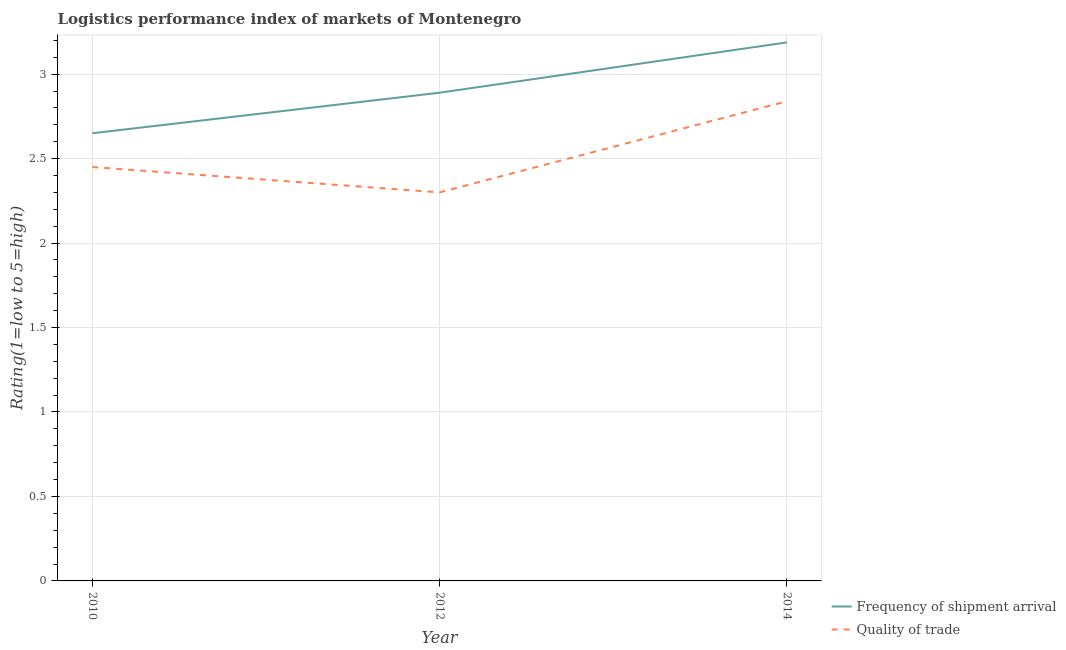Is the number of lines equal to the number of legend labels?
Offer a terse response. Yes. What is the lpi of frequency of shipment arrival in 2014?
Your answer should be compact. 3.19. Across all years, what is the maximum lpi of frequency of shipment arrival?
Provide a succinct answer. 3.19. Across all years, what is the minimum lpi of frequency of shipment arrival?
Your response must be concise. 2.65. In which year was the lpi quality of trade maximum?
Make the answer very short. 2014. What is the total lpi quality of trade in the graph?
Give a very brief answer. 7.59. What is the difference between the lpi quality of trade in 2012 and that in 2014?
Give a very brief answer. -0.54. What is the difference between the lpi of frequency of shipment arrival in 2012 and the lpi quality of trade in 2014?
Provide a succinct answer. 0.05. What is the average lpi quality of trade per year?
Your answer should be very brief. 2.53. In the year 2012, what is the difference between the lpi quality of trade and lpi of frequency of shipment arrival?
Give a very brief answer. -0.59. What is the ratio of the lpi of frequency of shipment arrival in 2010 to that in 2012?
Give a very brief answer. 0.92. Is the lpi of frequency of shipment arrival in 2010 less than that in 2014?
Provide a short and direct response. Yes. Is the difference between the lpi quality of trade in 2010 and 2012 greater than the difference between the lpi of frequency of shipment arrival in 2010 and 2012?
Offer a very short reply. Yes. What is the difference between the highest and the second highest lpi of frequency of shipment arrival?
Your answer should be very brief. 0.3. What is the difference between the highest and the lowest lpi of frequency of shipment arrival?
Give a very brief answer. 0.54. In how many years, is the lpi quality of trade greater than the average lpi quality of trade taken over all years?
Your response must be concise. 1. Is the sum of the lpi quality of trade in 2010 and 2012 greater than the maximum lpi of frequency of shipment arrival across all years?
Offer a very short reply. Yes. Does the lpi of frequency of shipment arrival monotonically increase over the years?
Your response must be concise. Yes. How many lines are there?
Provide a succinct answer. 2. How many years are there in the graph?
Your answer should be compact. 3. How many legend labels are there?
Make the answer very short. 2. What is the title of the graph?
Provide a short and direct response. Logistics performance index of markets of Montenegro. What is the label or title of the Y-axis?
Your response must be concise. Rating(1=low to 5=high). What is the Rating(1=low to 5=high) in Frequency of shipment arrival in 2010?
Provide a succinct answer. 2.65. What is the Rating(1=low to 5=high) in Quality of trade in 2010?
Keep it short and to the point. 2.45. What is the Rating(1=low to 5=high) of Frequency of shipment arrival in 2012?
Your response must be concise. 2.89. What is the Rating(1=low to 5=high) of Quality of trade in 2012?
Keep it short and to the point. 2.3. What is the Rating(1=low to 5=high) of Frequency of shipment arrival in 2014?
Your response must be concise. 3.19. What is the Rating(1=low to 5=high) of Quality of trade in 2014?
Offer a terse response. 2.84. Across all years, what is the maximum Rating(1=low to 5=high) of Frequency of shipment arrival?
Keep it short and to the point. 3.19. Across all years, what is the maximum Rating(1=low to 5=high) in Quality of trade?
Offer a very short reply. 2.84. Across all years, what is the minimum Rating(1=low to 5=high) of Frequency of shipment arrival?
Offer a very short reply. 2.65. Across all years, what is the minimum Rating(1=low to 5=high) of Quality of trade?
Provide a succinct answer. 2.3. What is the total Rating(1=low to 5=high) in Frequency of shipment arrival in the graph?
Keep it short and to the point. 8.73. What is the total Rating(1=low to 5=high) in Quality of trade in the graph?
Offer a very short reply. 7.59. What is the difference between the Rating(1=low to 5=high) in Frequency of shipment arrival in 2010 and that in 2012?
Your answer should be compact. -0.24. What is the difference between the Rating(1=low to 5=high) of Quality of trade in 2010 and that in 2012?
Offer a terse response. 0.15. What is the difference between the Rating(1=low to 5=high) in Frequency of shipment arrival in 2010 and that in 2014?
Give a very brief answer. -0.54. What is the difference between the Rating(1=low to 5=high) of Quality of trade in 2010 and that in 2014?
Provide a short and direct response. -0.39. What is the difference between the Rating(1=low to 5=high) in Frequency of shipment arrival in 2012 and that in 2014?
Offer a terse response. -0.3. What is the difference between the Rating(1=low to 5=high) of Quality of trade in 2012 and that in 2014?
Offer a terse response. -0.54. What is the difference between the Rating(1=low to 5=high) of Frequency of shipment arrival in 2010 and the Rating(1=low to 5=high) of Quality of trade in 2012?
Make the answer very short. 0.35. What is the difference between the Rating(1=low to 5=high) in Frequency of shipment arrival in 2010 and the Rating(1=low to 5=high) in Quality of trade in 2014?
Offer a terse response. -0.19. What is the difference between the Rating(1=low to 5=high) in Frequency of shipment arrival in 2012 and the Rating(1=low to 5=high) in Quality of trade in 2014?
Ensure brevity in your answer.  0.05. What is the average Rating(1=low to 5=high) of Frequency of shipment arrival per year?
Offer a very short reply. 2.91. What is the average Rating(1=low to 5=high) of Quality of trade per year?
Your response must be concise. 2.53. In the year 2012, what is the difference between the Rating(1=low to 5=high) of Frequency of shipment arrival and Rating(1=low to 5=high) of Quality of trade?
Provide a short and direct response. 0.59. In the year 2014, what is the difference between the Rating(1=low to 5=high) of Frequency of shipment arrival and Rating(1=low to 5=high) of Quality of trade?
Keep it short and to the point. 0.35. What is the ratio of the Rating(1=low to 5=high) in Frequency of shipment arrival in 2010 to that in 2012?
Keep it short and to the point. 0.92. What is the ratio of the Rating(1=low to 5=high) in Quality of trade in 2010 to that in 2012?
Your answer should be compact. 1.07. What is the ratio of the Rating(1=low to 5=high) in Frequency of shipment arrival in 2010 to that in 2014?
Ensure brevity in your answer.  0.83. What is the ratio of the Rating(1=low to 5=high) of Quality of trade in 2010 to that in 2014?
Provide a succinct answer. 0.86. What is the ratio of the Rating(1=low to 5=high) in Frequency of shipment arrival in 2012 to that in 2014?
Your answer should be very brief. 0.91. What is the ratio of the Rating(1=low to 5=high) in Quality of trade in 2012 to that in 2014?
Make the answer very short. 0.81. What is the difference between the highest and the second highest Rating(1=low to 5=high) in Frequency of shipment arrival?
Offer a very short reply. 0.3. What is the difference between the highest and the second highest Rating(1=low to 5=high) of Quality of trade?
Provide a succinct answer. 0.39. What is the difference between the highest and the lowest Rating(1=low to 5=high) in Frequency of shipment arrival?
Keep it short and to the point. 0.54. What is the difference between the highest and the lowest Rating(1=low to 5=high) in Quality of trade?
Your answer should be very brief. 0.54. 